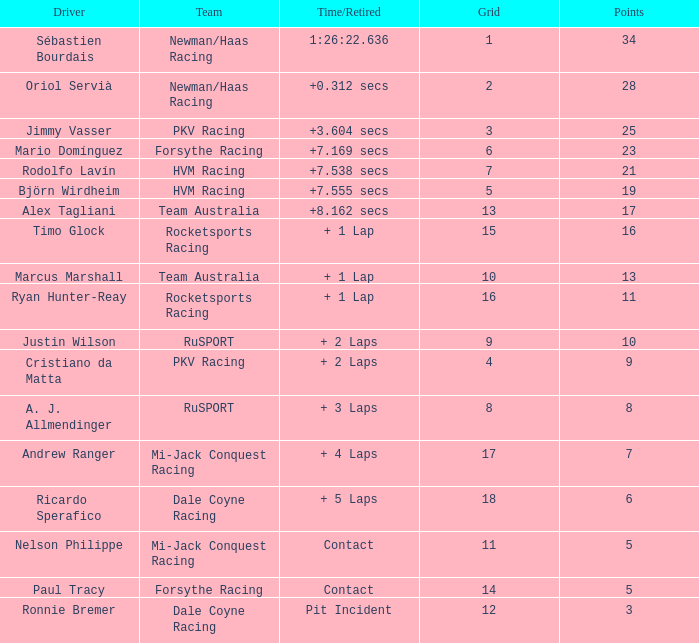538 secs? 21.0. 